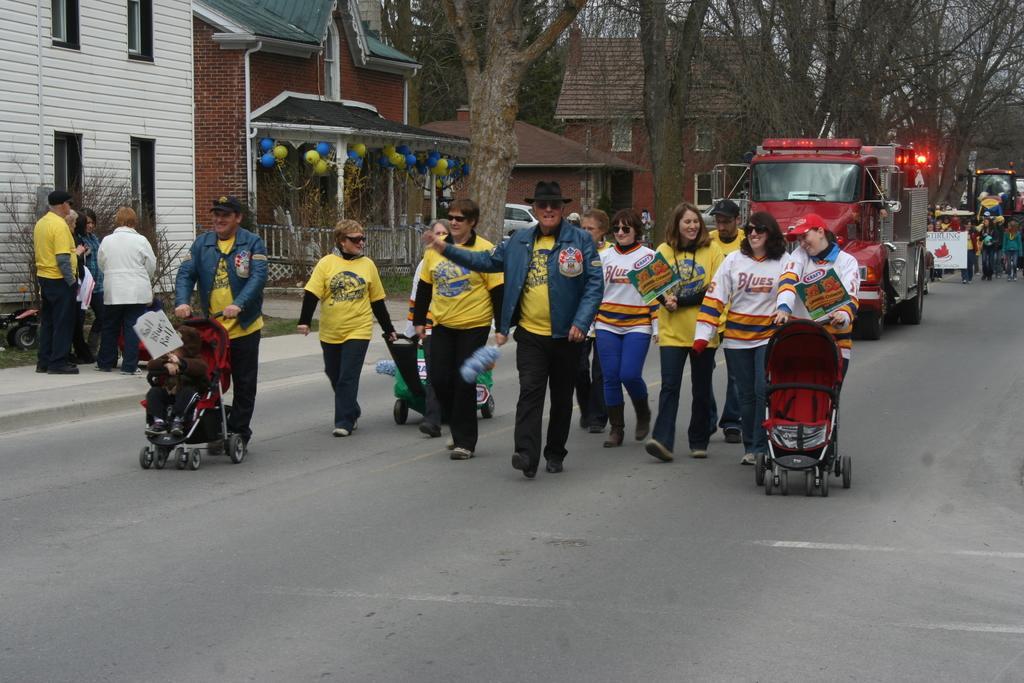Describe this image in one or two sentences. In the middle of the image few people are walking and holding strollers. Behind them there are some vehicles. At the top of the image there are some trees and buildings. 